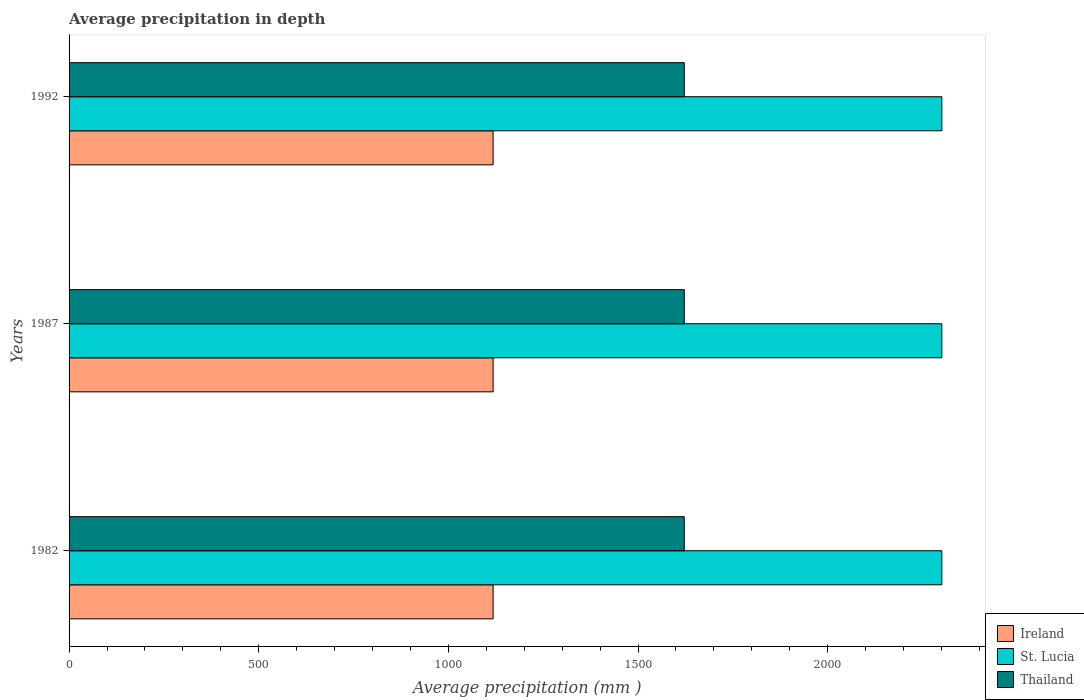How many groups of bars are there?
Give a very brief answer. 3. Are the number of bars per tick equal to the number of legend labels?
Make the answer very short. Yes. How many bars are there on the 1st tick from the bottom?
Offer a very short reply. 3. What is the average precipitation in Thailand in 1987?
Your answer should be compact. 1622. Across all years, what is the maximum average precipitation in Thailand?
Make the answer very short. 1622. Across all years, what is the minimum average precipitation in Ireland?
Make the answer very short. 1118. In which year was the average precipitation in St. Lucia maximum?
Offer a terse response. 1982. What is the total average precipitation in Ireland in the graph?
Ensure brevity in your answer.  3354. What is the difference between the average precipitation in Thailand in 1987 and the average precipitation in Ireland in 1982?
Your answer should be very brief. 504. What is the average average precipitation in St. Lucia per year?
Your answer should be very brief. 2301. In the year 1992, what is the difference between the average precipitation in Ireland and average precipitation in Thailand?
Make the answer very short. -504. In how many years, is the average precipitation in Ireland greater than 2300 mm?
Your response must be concise. 0. What is the ratio of the average precipitation in Ireland in 1987 to that in 1992?
Provide a succinct answer. 1. Is the average precipitation in Thailand in 1987 less than that in 1992?
Keep it short and to the point. No. What does the 1st bar from the top in 1982 represents?
Your answer should be very brief. Thailand. What does the 1st bar from the bottom in 1982 represents?
Your response must be concise. Ireland. Is it the case that in every year, the sum of the average precipitation in St. Lucia and average precipitation in Ireland is greater than the average precipitation in Thailand?
Offer a very short reply. Yes. How many bars are there?
Offer a terse response. 9. How many years are there in the graph?
Offer a terse response. 3. What is the difference between two consecutive major ticks on the X-axis?
Your answer should be compact. 500. Are the values on the major ticks of X-axis written in scientific E-notation?
Provide a succinct answer. No. Does the graph contain any zero values?
Your answer should be compact. No. Does the graph contain grids?
Provide a short and direct response. No. Where does the legend appear in the graph?
Ensure brevity in your answer.  Bottom right. How many legend labels are there?
Your response must be concise. 3. How are the legend labels stacked?
Offer a terse response. Vertical. What is the title of the graph?
Give a very brief answer. Average precipitation in depth. What is the label or title of the X-axis?
Your answer should be compact. Average precipitation (mm ). What is the Average precipitation (mm ) in Ireland in 1982?
Provide a short and direct response. 1118. What is the Average precipitation (mm ) in St. Lucia in 1982?
Provide a short and direct response. 2301. What is the Average precipitation (mm ) of Thailand in 1982?
Provide a succinct answer. 1622. What is the Average precipitation (mm ) of Ireland in 1987?
Offer a very short reply. 1118. What is the Average precipitation (mm ) of St. Lucia in 1987?
Keep it short and to the point. 2301. What is the Average precipitation (mm ) of Thailand in 1987?
Ensure brevity in your answer.  1622. What is the Average precipitation (mm ) in Ireland in 1992?
Your response must be concise. 1118. What is the Average precipitation (mm ) in St. Lucia in 1992?
Offer a very short reply. 2301. What is the Average precipitation (mm ) in Thailand in 1992?
Give a very brief answer. 1622. Across all years, what is the maximum Average precipitation (mm ) of Ireland?
Offer a very short reply. 1118. Across all years, what is the maximum Average precipitation (mm ) in St. Lucia?
Your response must be concise. 2301. Across all years, what is the maximum Average precipitation (mm ) in Thailand?
Provide a succinct answer. 1622. Across all years, what is the minimum Average precipitation (mm ) in Ireland?
Provide a succinct answer. 1118. Across all years, what is the minimum Average precipitation (mm ) in St. Lucia?
Keep it short and to the point. 2301. Across all years, what is the minimum Average precipitation (mm ) in Thailand?
Provide a short and direct response. 1622. What is the total Average precipitation (mm ) of Ireland in the graph?
Offer a very short reply. 3354. What is the total Average precipitation (mm ) in St. Lucia in the graph?
Keep it short and to the point. 6903. What is the total Average precipitation (mm ) of Thailand in the graph?
Provide a succinct answer. 4866. What is the difference between the Average precipitation (mm ) in Ireland in 1982 and that in 1987?
Offer a very short reply. 0. What is the difference between the Average precipitation (mm ) of St. Lucia in 1982 and that in 1987?
Make the answer very short. 0. What is the difference between the Average precipitation (mm ) in Ireland in 1982 and that in 1992?
Provide a succinct answer. 0. What is the difference between the Average precipitation (mm ) in Thailand in 1987 and that in 1992?
Provide a succinct answer. 0. What is the difference between the Average precipitation (mm ) in Ireland in 1982 and the Average precipitation (mm ) in St. Lucia in 1987?
Keep it short and to the point. -1183. What is the difference between the Average precipitation (mm ) in Ireland in 1982 and the Average precipitation (mm ) in Thailand in 1987?
Make the answer very short. -504. What is the difference between the Average precipitation (mm ) of St. Lucia in 1982 and the Average precipitation (mm ) of Thailand in 1987?
Make the answer very short. 679. What is the difference between the Average precipitation (mm ) of Ireland in 1982 and the Average precipitation (mm ) of St. Lucia in 1992?
Keep it short and to the point. -1183. What is the difference between the Average precipitation (mm ) of Ireland in 1982 and the Average precipitation (mm ) of Thailand in 1992?
Make the answer very short. -504. What is the difference between the Average precipitation (mm ) of St. Lucia in 1982 and the Average precipitation (mm ) of Thailand in 1992?
Provide a succinct answer. 679. What is the difference between the Average precipitation (mm ) of Ireland in 1987 and the Average precipitation (mm ) of St. Lucia in 1992?
Keep it short and to the point. -1183. What is the difference between the Average precipitation (mm ) in Ireland in 1987 and the Average precipitation (mm ) in Thailand in 1992?
Your answer should be compact. -504. What is the difference between the Average precipitation (mm ) in St. Lucia in 1987 and the Average precipitation (mm ) in Thailand in 1992?
Offer a terse response. 679. What is the average Average precipitation (mm ) in Ireland per year?
Keep it short and to the point. 1118. What is the average Average precipitation (mm ) of St. Lucia per year?
Offer a terse response. 2301. What is the average Average precipitation (mm ) in Thailand per year?
Your answer should be very brief. 1622. In the year 1982, what is the difference between the Average precipitation (mm ) of Ireland and Average precipitation (mm ) of St. Lucia?
Your answer should be compact. -1183. In the year 1982, what is the difference between the Average precipitation (mm ) in Ireland and Average precipitation (mm ) in Thailand?
Your answer should be compact. -504. In the year 1982, what is the difference between the Average precipitation (mm ) of St. Lucia and Average precipitation (mm ) of Thailand?
Ensure brevity in your answer.  679. In the year 1987, what is the difference between the Average precipitation (mm ) of Ireland and Average precipitation (mm ) of St. Lucia?
Make the answer very short. -1183. In the year 1987, what is the difference between the Average precipitation (mm ) in Ireland and Average precipitation (mm ) in Thailand?
Provide a succinct answer. -504. In the year 1987, what is the difference between the Average precipitation (mm ) of St. Lucia and Average precipitation (mm ) of Thailand?
Your response must be concise. 679. In the year 1992, what is the difference between the Average precipitation (mm ) in Ireland and Average precipitation (mm ) in St. Lucia?
Make the answer very short. -1183. In the year 1992, what is the difference between the Average precipitation (mm ) of Ireland and Average precipitation (mm ) of Thailand?
Offer a very short reply. -504. In the year 1992, what is the difference between the Average precipitation (mm ) of St. Lucia and Average precipitation (mm ) of Thailand?
Ensure brevity in your answer.  679. What is the ratio of the Average precipitation (mm ) of Ireland in 1982 to that in 1992?
Provide a short and direct response. 1. What is the ratio of the Average precipitation (mm ) in St. Lucia in 1987 to that in 1992?
Offer a terse response. 1. What is the ratio of the Average precipitation (mm ) of Thailand in 1987 to that in 1992?
Provide a short and direct response. 1. What is the difference between the highest and the second highest Average precipitation (mm ) in St. Lucia?
Your answer should be compact. 0. What is the difference between the highest and the second highest Average precipitation (mm ) of Thailand?
Provide a short and direct response. 0. 